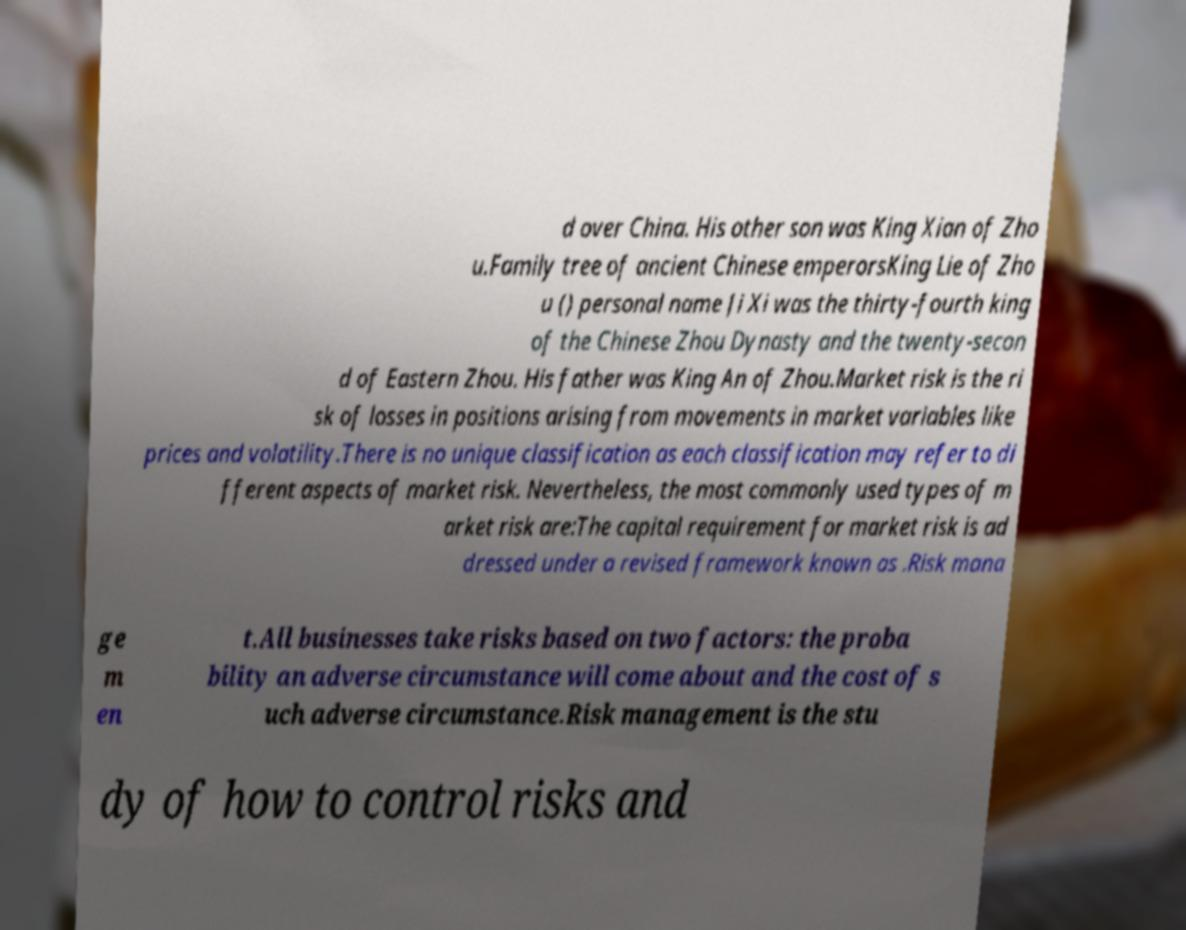There's text embedded in this image that I need extracted. Can you transcribe it verbatim? d over China. His other son was King Xian of Zho u.Family tree of ancient Chinese emperorsKing Lie of Zho u () personal name Ji Xi was the thirty-fourth king of the Chinese Zhou Dynasty and the twenty-secon d of Eastern Zhou. His father was King An of Zhou.Market risk is the ri sk of losses in positions arising from movements in market variables like prices and volatility.There is no unique classification as each classification may refer to di fferent aspects of market risk. Nevertheless, the most commonly used types of m arket risk are:The capital requirement for market risk is ad dressed under a revised framework known as .Risk mana ge m en t.All businesses take risks based on two factors: the proba bility an adverse circumstance will come about and the cost of s uch adverse circumstance.Risk management is the stu dy of how to control risks and 